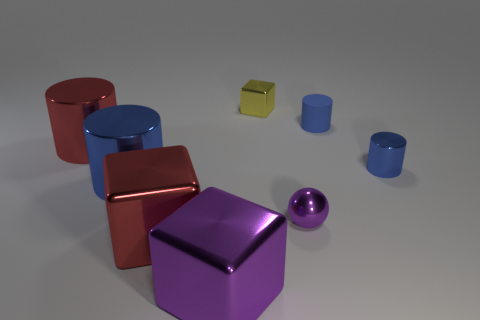Do the small metal object on the right side of the matte thing and the metal cube that is behind the purple ball have the same color?
Offer a terse response. No. What is the shape of the large red thing behind the purple metallic thing that is behind the large purple block?
Your response must be concise. Cylinder. Is there a purple ball of the same size as the red metal block?
Give a very brief answer. No. How many small yellow metal things have the same shape as the large purple object?
Provide a short and direct response. 1. Are there the same number of small yellow metal things that are on the left side of the small yellow shiny block and rubber cylinders in front of the large purple metal block?
Your response must be concise. Yes. Are any cyan metal objects visible?
Your answer should be very brief. No. What is the size of the metallic cylinder that is right of the purple shiny thing that is to the left of the shiny block that is behind the tiny purple metal thing?
Keep it short and to the point. Small. What is the shape of the yellow shiny thing that is the same size as the sphere?
Provide a succinct answer. Cube. Is there any other thing that is the same material as the ball?
Make the answer very short. Yes. What number of objects are either metal cylinders on the left side of the tiny blue rubber thing or blue metal spheres?
Keep it short and to the point. 2. 